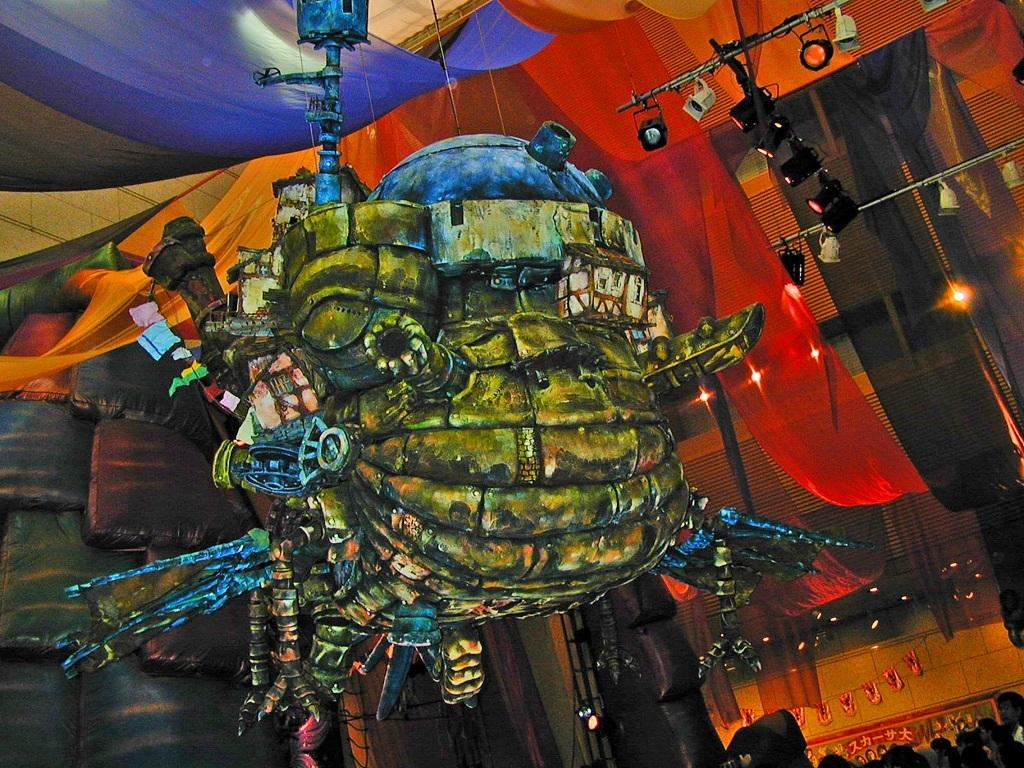What can be seen hanging in the image? There is a big toy hanging in the image. What else is present in the image besides the toy? There are people standing in the image. Are there any visible light sources in the image? Yes, there are lights visible in the image. What is an unusual detail about the image? There are clothes on the roof in the image. How many dogs are visible in the image? There are no dogs present in the image. What type of adjustment can be made to the lights in the image? The question is not relevant to the image, as it does not mention any adjustments or controls for the lights. 